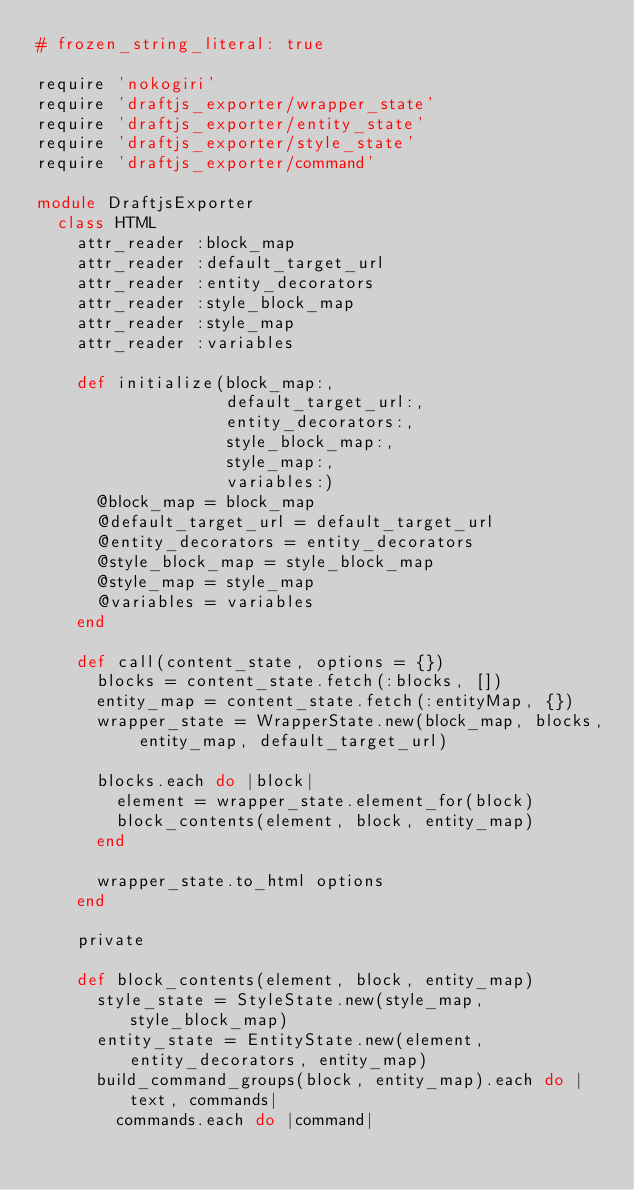Convert code to text. <code><loc_0><loc_0><loc_500><loc_500><_Ruby_># frozen_string_literal: true

require 'nokogiri'
require 'draftjs_exporter/wrapper_state'
require 'draftjs_exporter/entity_state'
require 'draftjs_exporter/style_state'
require 'draftjs_exporter/command'

module DraftjsExporter
  class HTML
    attr_reader :block_map
    attr_reader :default_target_url
    attr_reader :entity_decorators
    attr_reader :style_block_map
    attr_reader :style_map
    attr_reader :variables

    def initialize(block_map:,
                   default_target_url:,
                   entity_decorators:,
                   style_block_map:,
                   style_map:,
                   variables:)
      @block_map = block_map
      @default_target_url = default_target_url
      @entity_decorators = entity_decorators
      @style_block_map = style_block_map
      @style_map = style_map
      @variables = variables
    end

    def call(content_state, options = {})
      blocks = content_state.fetch(:blocks, [])
      entity_map = content_state.fetch(:entityMap, {})
      wrapper_state = WrapperState.new(block_map, blocks, entity_map, default_target_url)

      blocks.each do |block|
        element = wrapper_state.element_for(block)
        block_contents(element, block, entity_map)
      end

      wrapper_state.to_html options
    end

    private

    def block_contents(element, block, entity_map)
      style_state = StyleState.new(style_map, style_block_map)
      entity_state = EntityState.new(element, entity_decorators, entity_map)
      build_command_groups(block, entity_map).each do |text, commands|
        commands.each do |command|</code> 